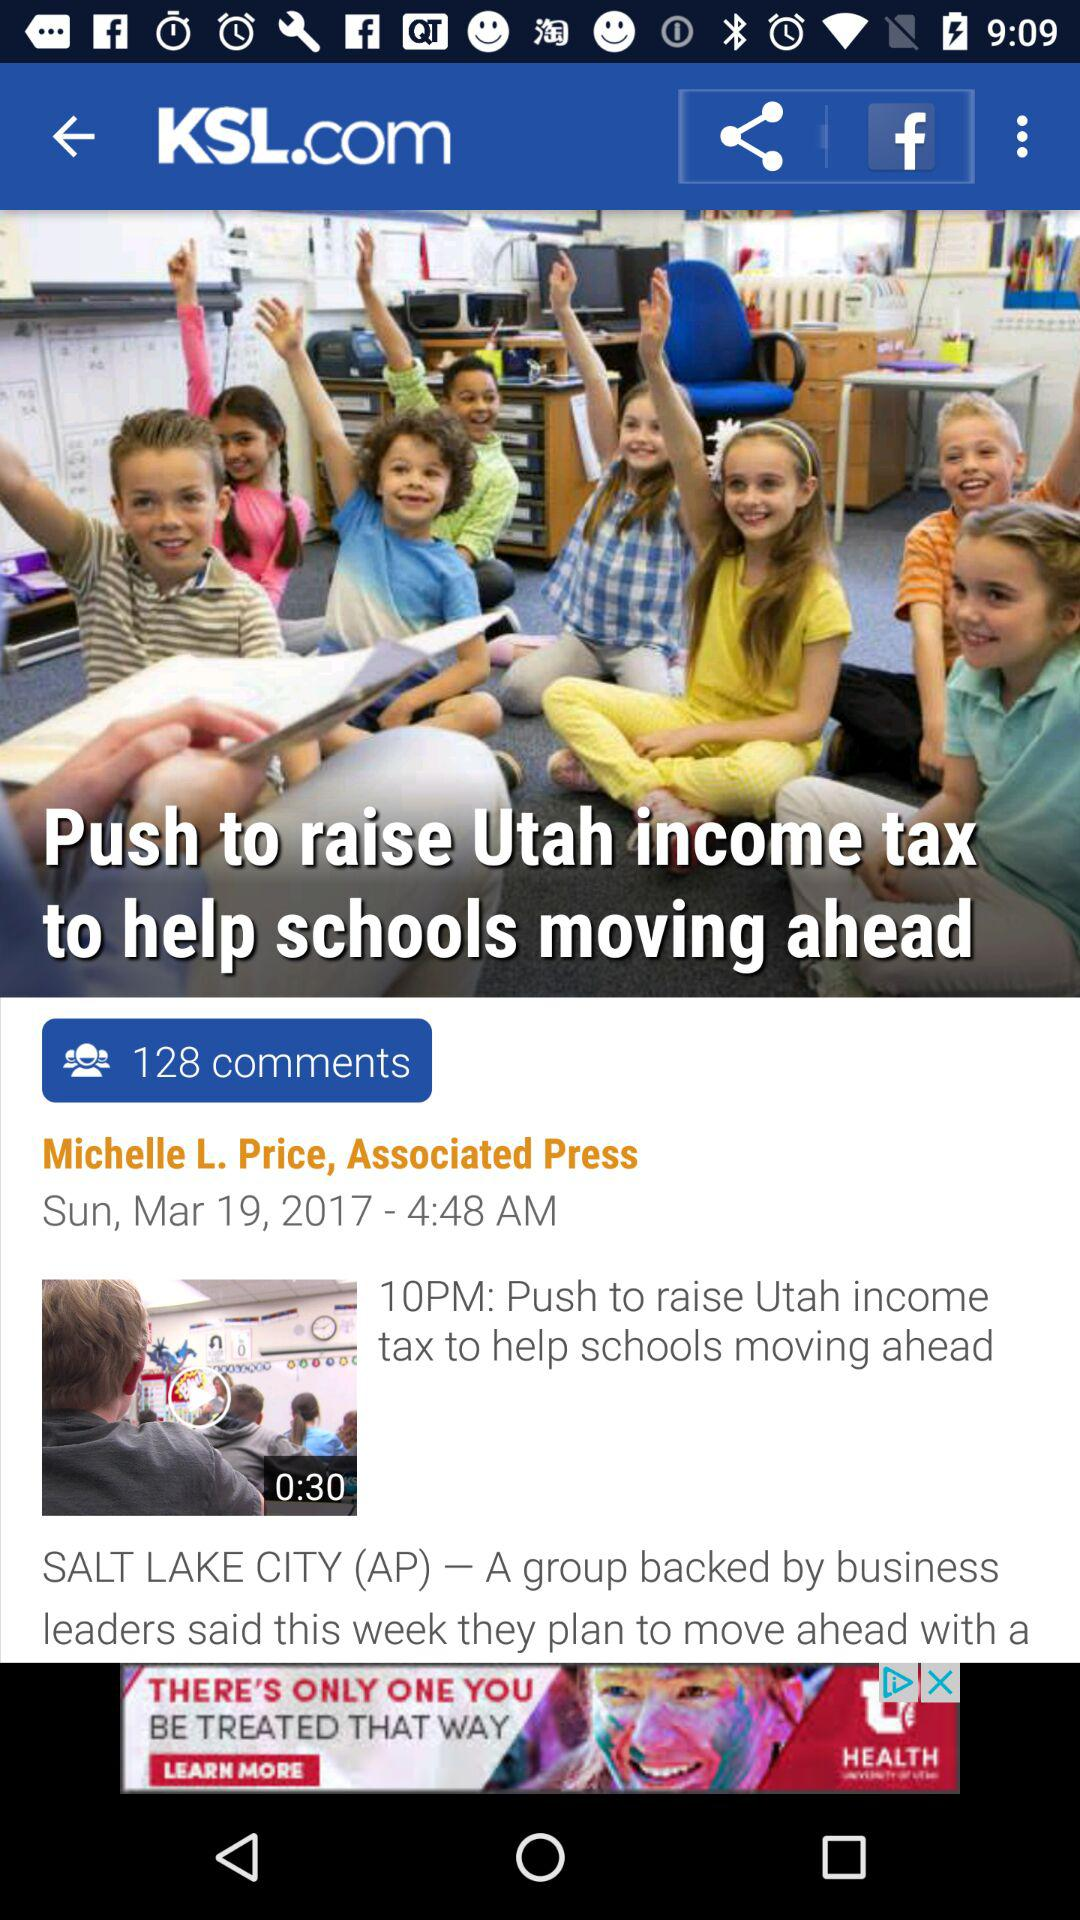How long is the video?
Answer the question using a single word or phrase. 0:30 